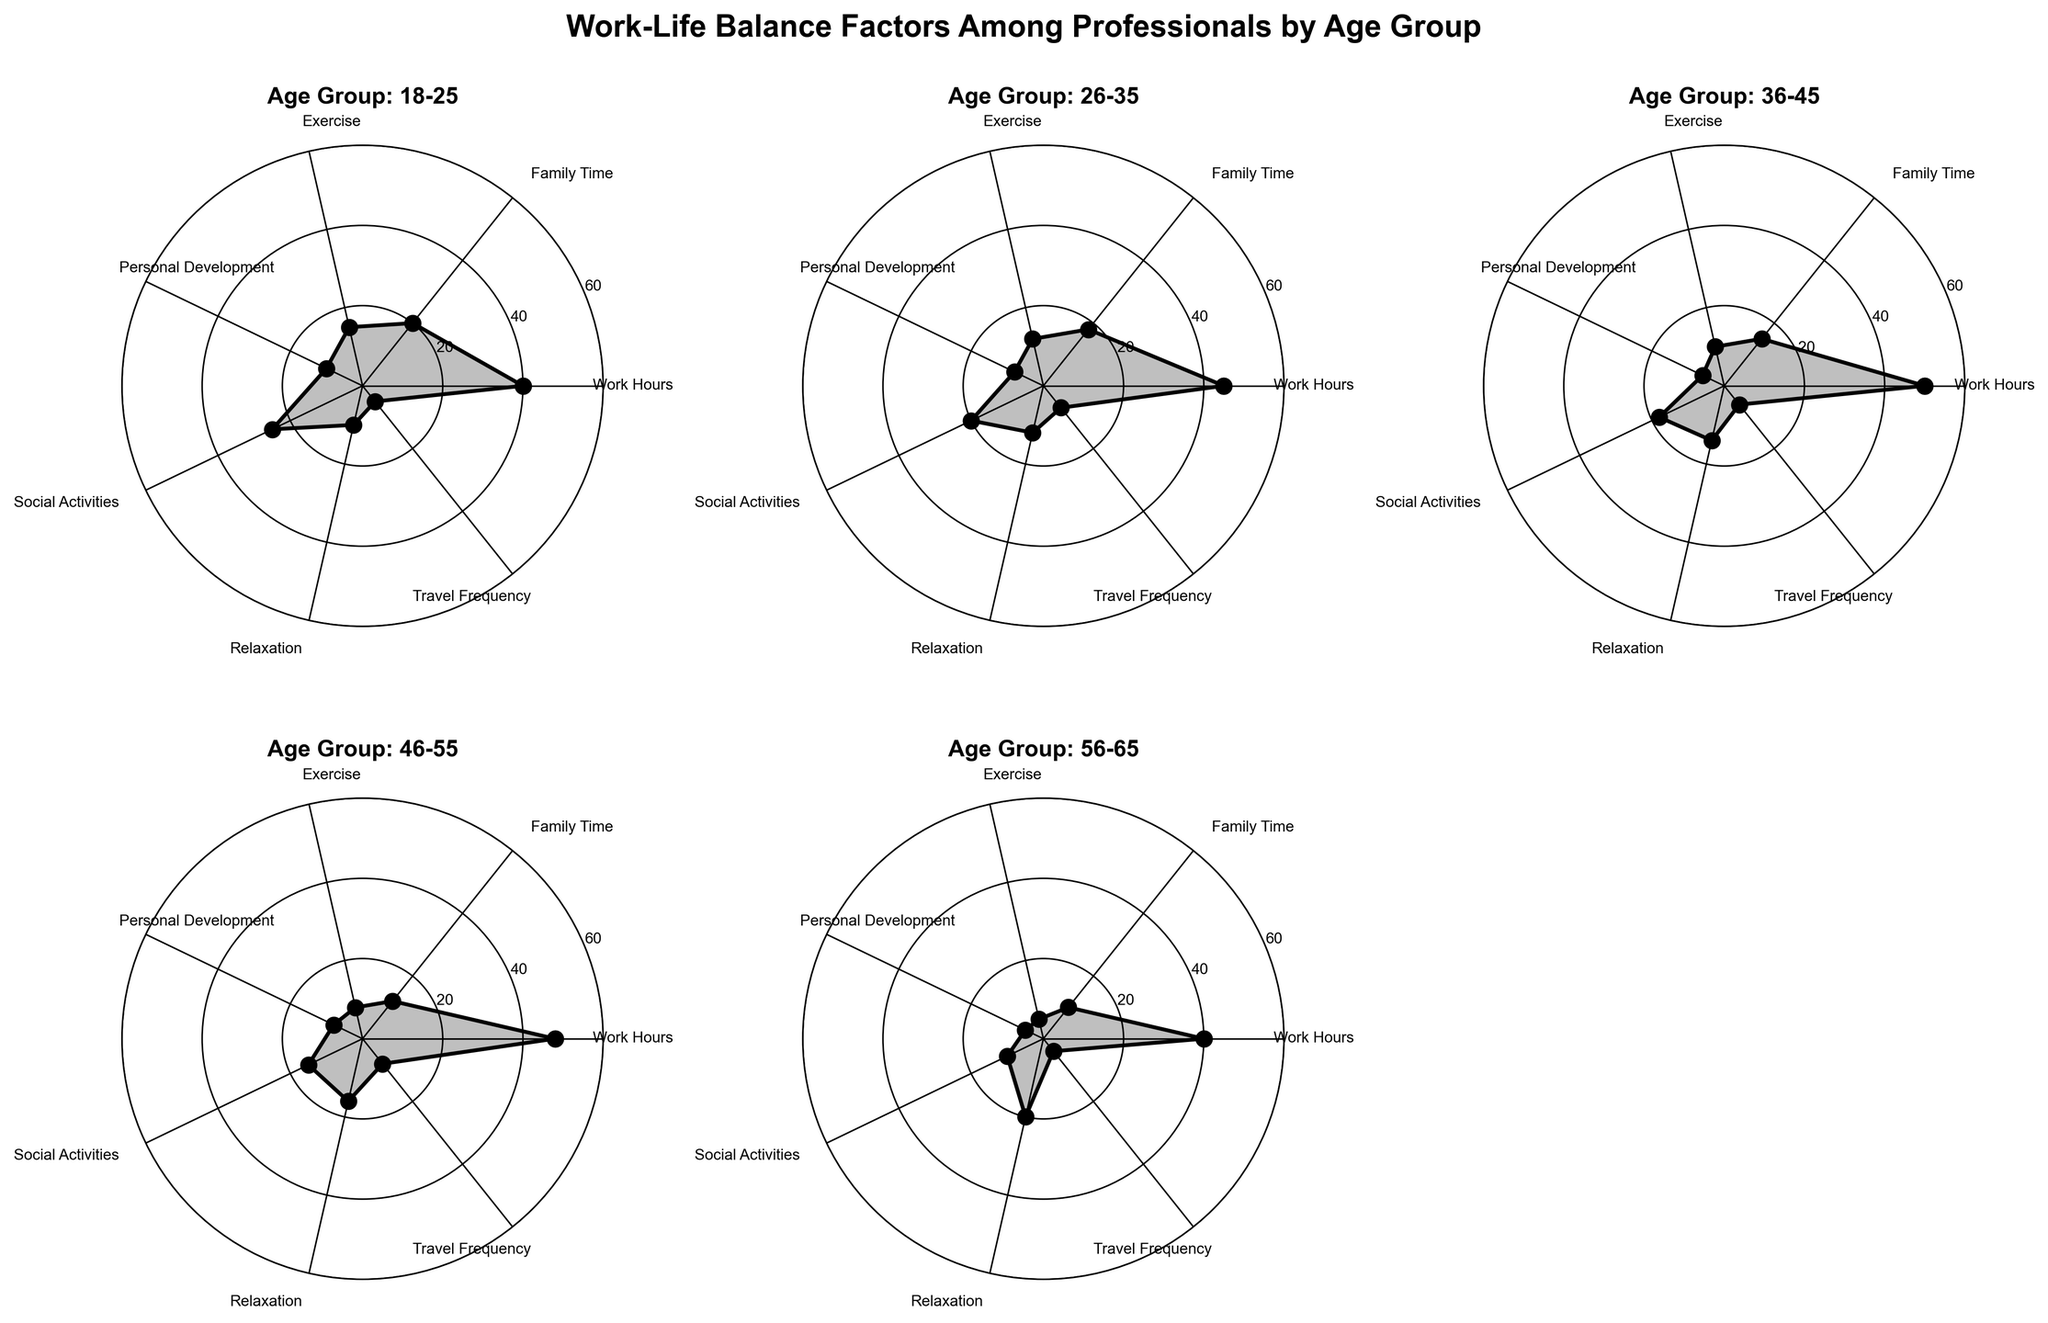What is the age group with the highest average exercise time? By examining the Exercise axis on each subplot, we can see that the age group with the highest average exercise time is 18-25 with 15 hours.
Answer: 18-25 Which age group spends the most time on work hours? Observing the Work Hours axis across the subplots, the age group 36-45 spends the most time on work with 50 hours.
Answer: 36-45 What is the average travel frequency for all age groups combined? Summing the Travel Frequency values for all age groups (5 + 7 + 6 + 8 + 4) gives 30. Dividing by the number of age groups (5), we get an average travel frequency of 6.
Answer: 6 Which age group has the least amount of family time? Looking at the Family Time axis, the age group 56-65 spends the least amount of time with 10 hours.
Answer: 56-65 How does the relaxation time compare between the 26-35 and 46-55 age groups? The relaxation time for the 26-35 age group is 12 hours, while the 46-55 age group has 16 hours. 46-55 spends 4 more hours on relaxation compared to 26-35.
Answer: 46-55 spends 4 more hours Which age group has the most balanced distribution among all categories? By examining each radar chart, the 18-25 age group appears to have the most even distribution across all categories, as all the values are neither too high nor too low compared to other age groups.
Answer: 18-25 What is the total time spent on personal development across all age groups? Summing the Personal Development values for all age groups (10 + 8 + 6 + 8 + 5) gives a total of 37 hours.
Answer: 37 hours Compare the social activities time between the youngest and the oldest age groups. The 18-25 age group spends 25 hours on social activities, while the 56-65 age group spends 10 hours. The youngest age group spends 15 more hours than the oldest age group.
Answer: 15 more hours in 18-25 Which two categories have the smallest difference in time for the 36-45 age group? Examining the radar chart for the 36-45 age group, the categories with the smallest difference in time are Travel Frequency (6) and Personal Development (6), both having the same value.
Answer: Travel Frequency and Personal Development What is the difference in work hours between the age groups 18-25 and 46-55? The 18-25 age group works 40 hours, and the 46-55 age group works 48 hours. The difference is 48 - 40 = 8 hours.
Answer: 8 hours 